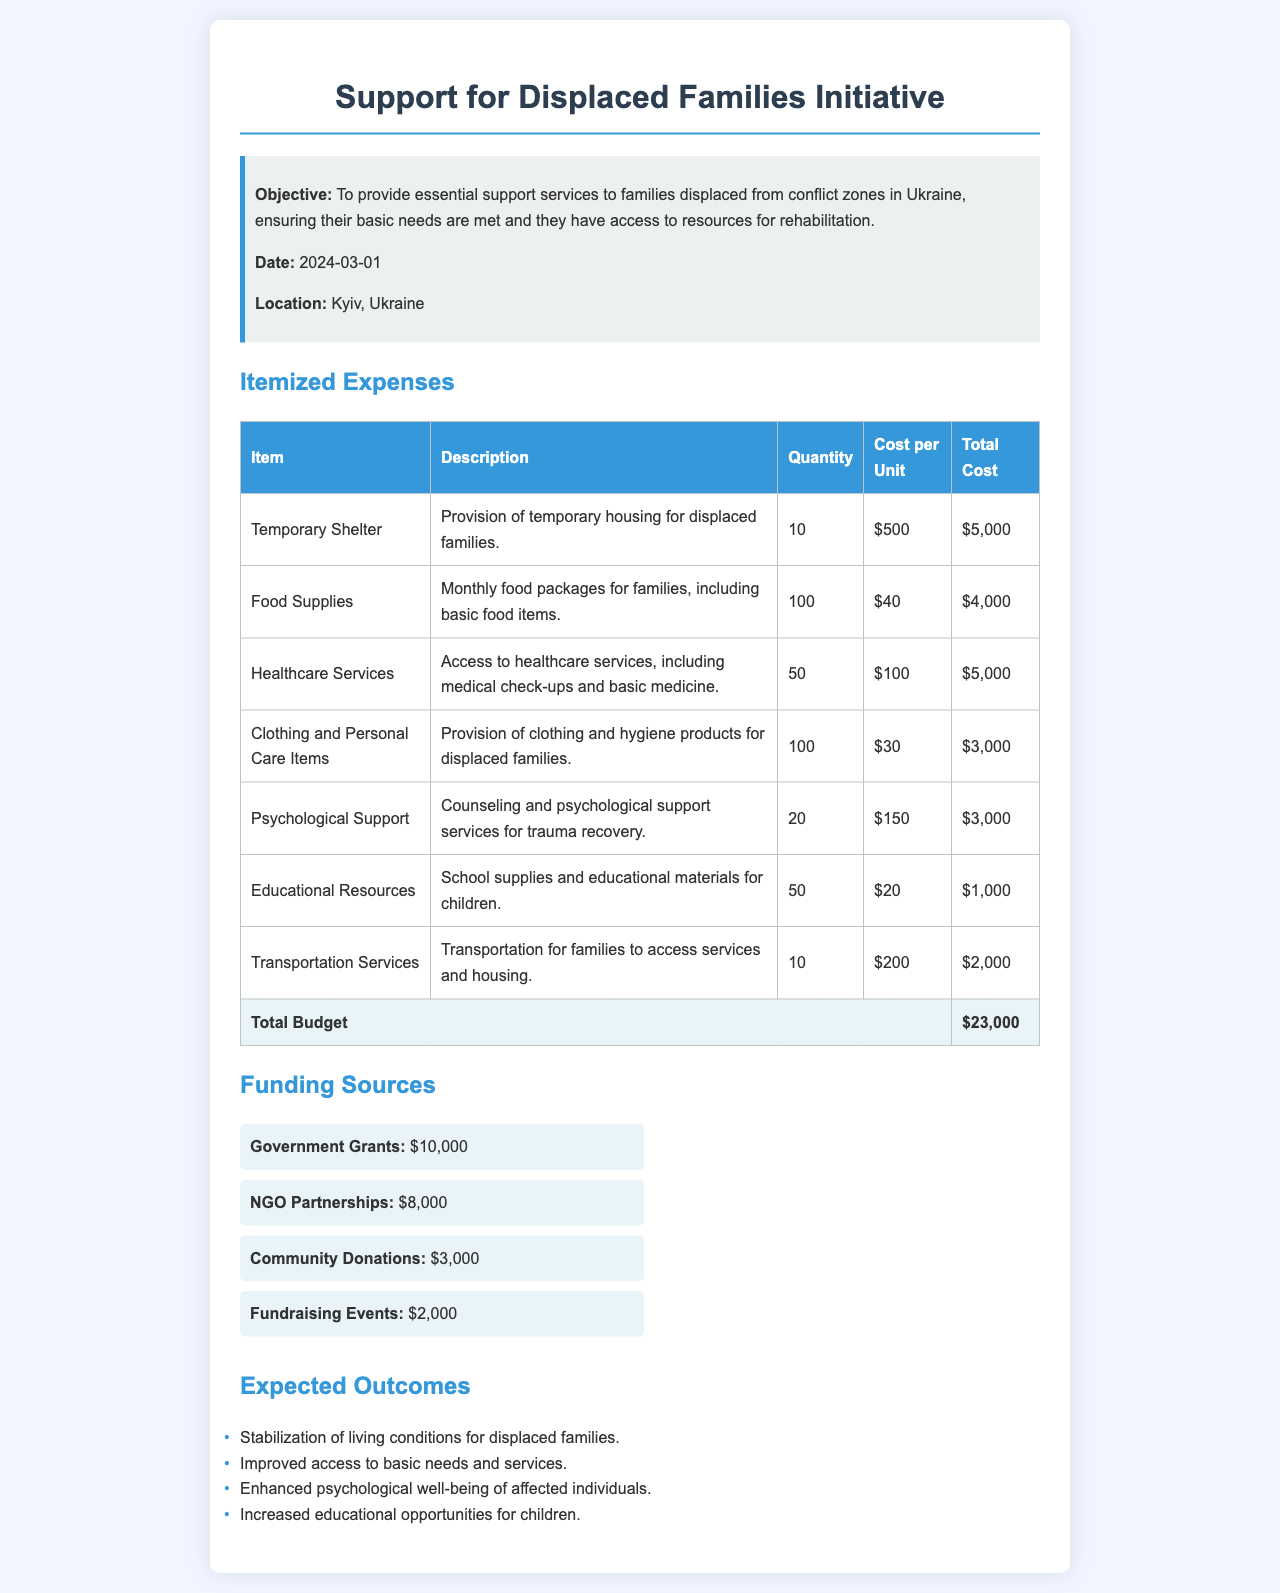What is the objective of the initiative? The objective is to provide essential support services to families displaced from conflict zones in Ukraine.
Answer: Provide essential support services to families displaced from conflict zones in Ukraine What is the total budget proposed? The total budget is found in the table summarizing all itemized expenses.
Answer: $23,000 How many temporary shelters are being proposed? The quantity of temporary shelters can be found in the itemized expenses table.
Answer: 10 What is the cost per unit for healthcare services? The cost per unit for healthcare services is listed in the itemized expenses.
Answer: $100 Which source provides the highest funding? The funding sources section indicates which source contributes the most.
Answer: Government Grants What is the total quantity of food supplies? The total quantity of food supplies is listed in the itemized expenses table.
Answer: 100 How many families will receive psychological support? The number of families receiving psychological support is outlined in the itemized expenses.
Answer: 20 What date is the initiative scheduled to start? The start date of the initiative is stated in the information box.
Answer: 2024-03-01 What types of items are included under clothing and personal care? The description in the itemized expenses identifies the type of items included.
Answer: Clothing and hygiene products 